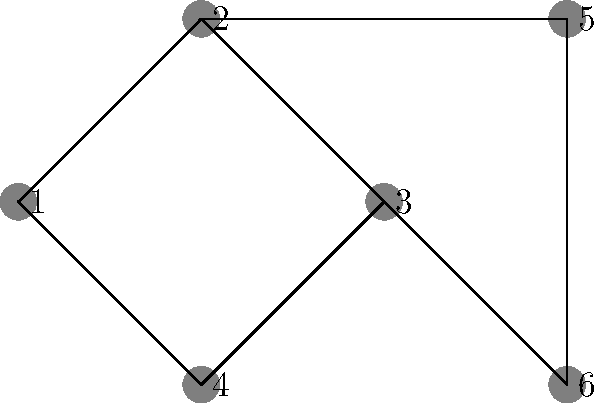Given the network topology shown in the diagram, which node should be chosen as the central hub to minimize the maximum number of hops required for any two nodes to communicate? Assume that messages can only be passed along the existing connections. To solve this problem, we need to analyze the network topology and calculate the maximum number of hops required for each node if it were to be the central hub. Here's a step-by-step approach:

1. For each node, calculate the maximum number of hops required to reach any other node:

   Node 1: Max 3 hops (to reach 5 or 6)
   Node 2: Max 2 hops (to reach 5 or 6)
   Node 3: Max 2 hops (to reach 4 or 5)
   Node 4: Max 3 hops (to reach 5 or 6)
   Node 5: Max 3 hops (to reach 1 or 4)
   Node 6: Max 3 hops (to reach 1 or 4)

2. Identify the node(s) with the minimum "maximum hops":
   Nodes 2 and 3 both have a maximum of 2 hops.

3. In case of a tie, we can consider the average number of hops:
   Node 2: (1 + 1 + 1 + 2 + 2) / 5 = 1.4
   Node 3: (1 + 1 + 1 + 2 + 2) / 5 = 1.4

Both nodes 2 and 3 have the same average, so either could be chosen. However, node 2 is more centrally located in the diagram, making it a slightly better choice for visualization purposes.

Therefore, node 2 is the optimal choice for the central hub, as it minimizes the maximum number of hops required for any two nodes to communicate.
Answer: Node 2 